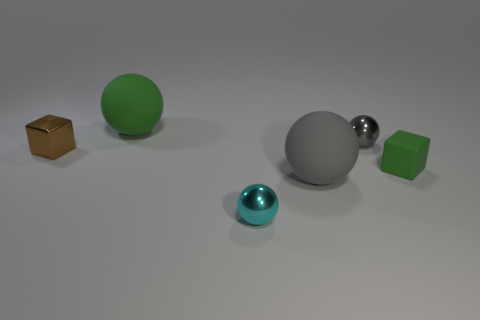How many gray spheres must be subtracted to get 1 gray spheres? 1 Subtract all purple spheres. Subtract all yellow cubes. How many spheres are left? 4 Add 4 green metallic cylinders. How many objects exist? 10 Subtract all spheres. How many objects are left? 2 Add 6 gray metal balls. How many gray metal balls exist? 7 Subtract 0 gray cylinders. How many objects are left? 6 Subtract all small green things. Subtract all big yellow metal things. How many objects are left? 5 Add 5 tiny green rubber objects. How many tiny green rubber objects are left? 6 